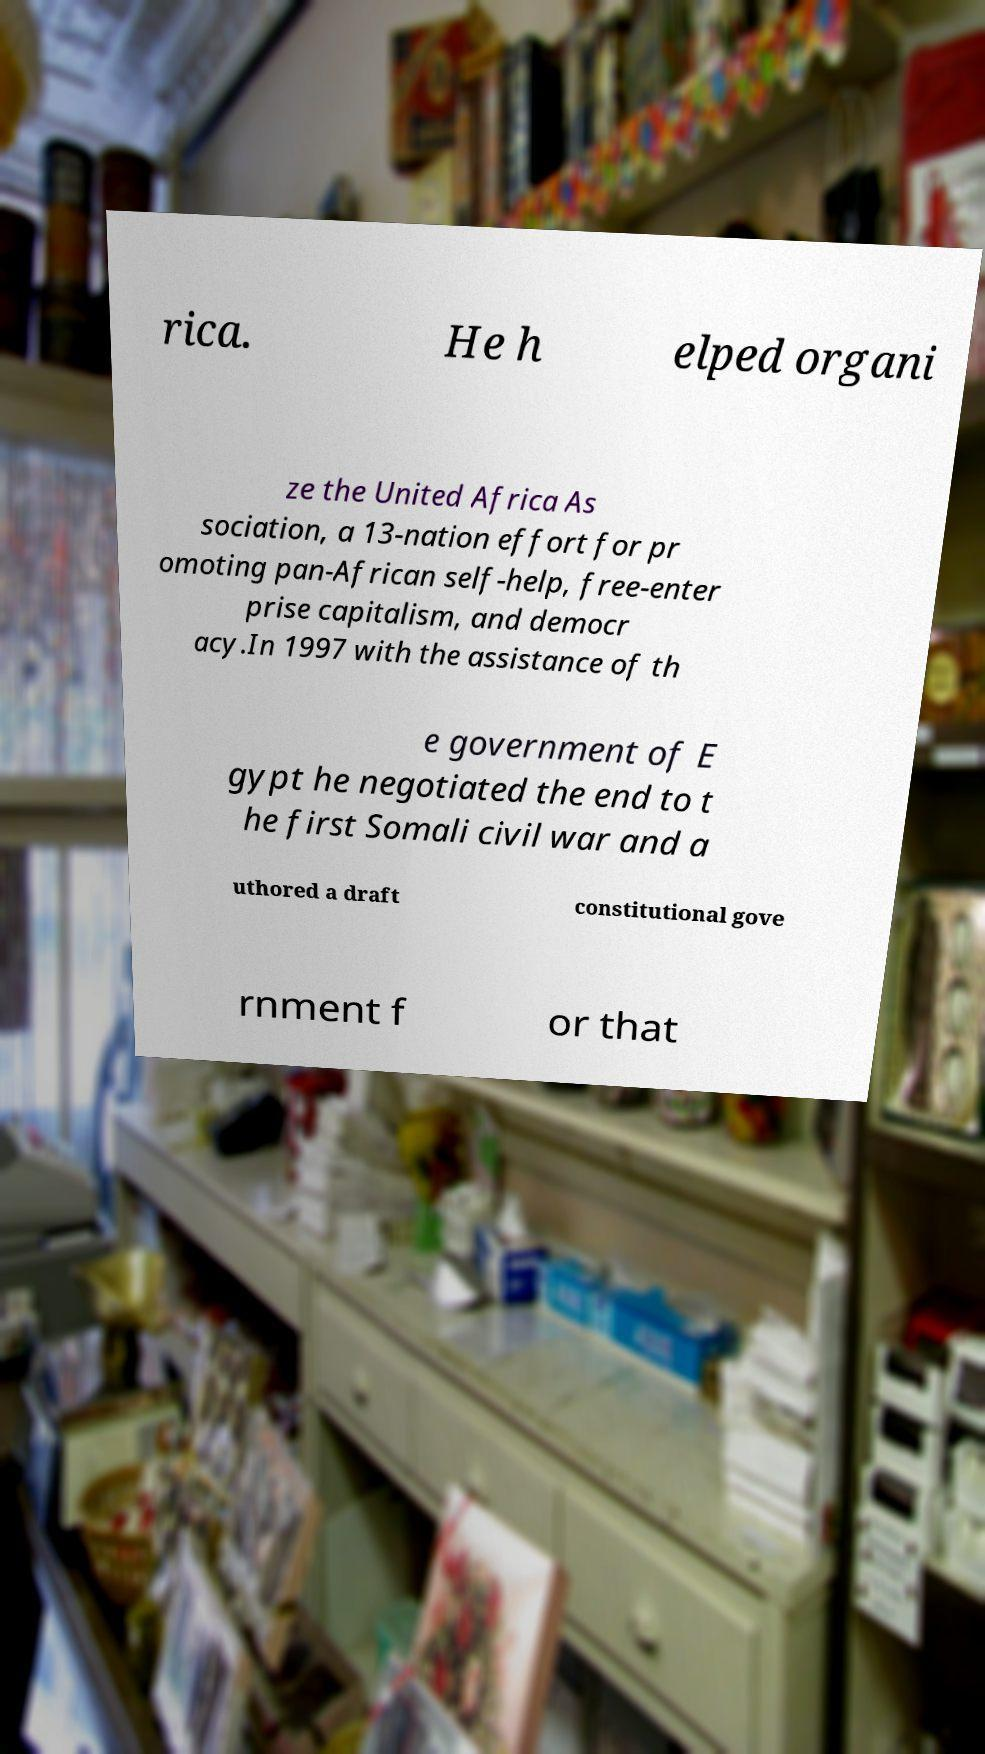Could you extract and type out the text from this image? rica. He h elped organi ze the United Africa As sociation, a 13-nation effort for pr omoting pan-African self-help, free-enter prise capitalism, and democr acy.In 1997 with the assistance of th e government of E gypt he negotiated the end to t he first Somali civil war and a uthored a draft constitutional gove rnment f or that 